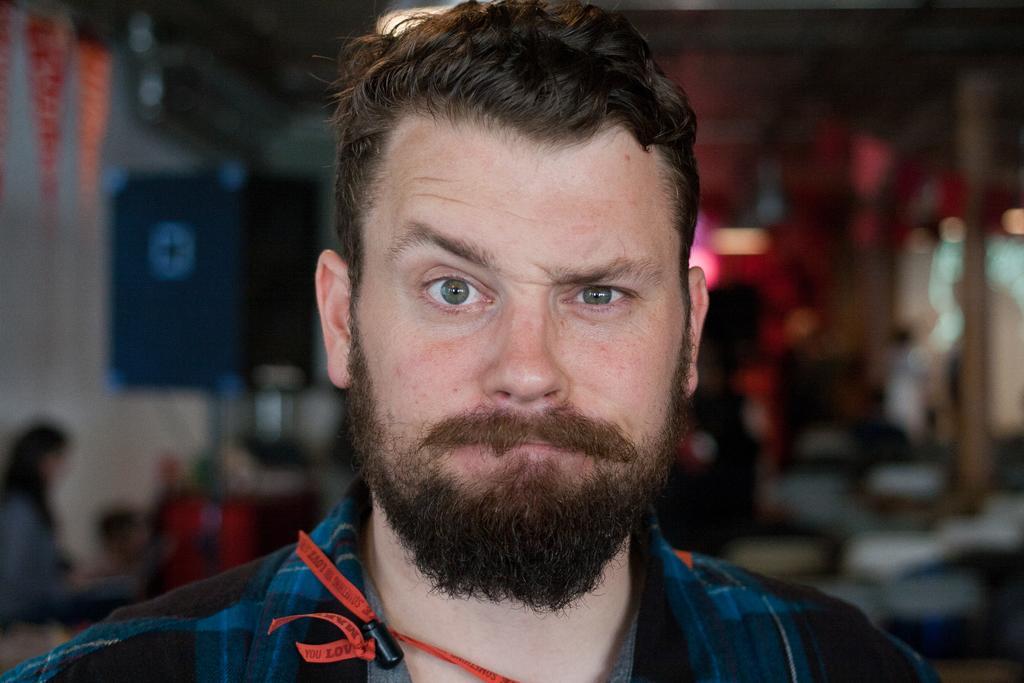Can you describe this image briefly? In the image we can see the close up picture of the man wearing clothes. Behind the man we can see a person and the background is blurred. 